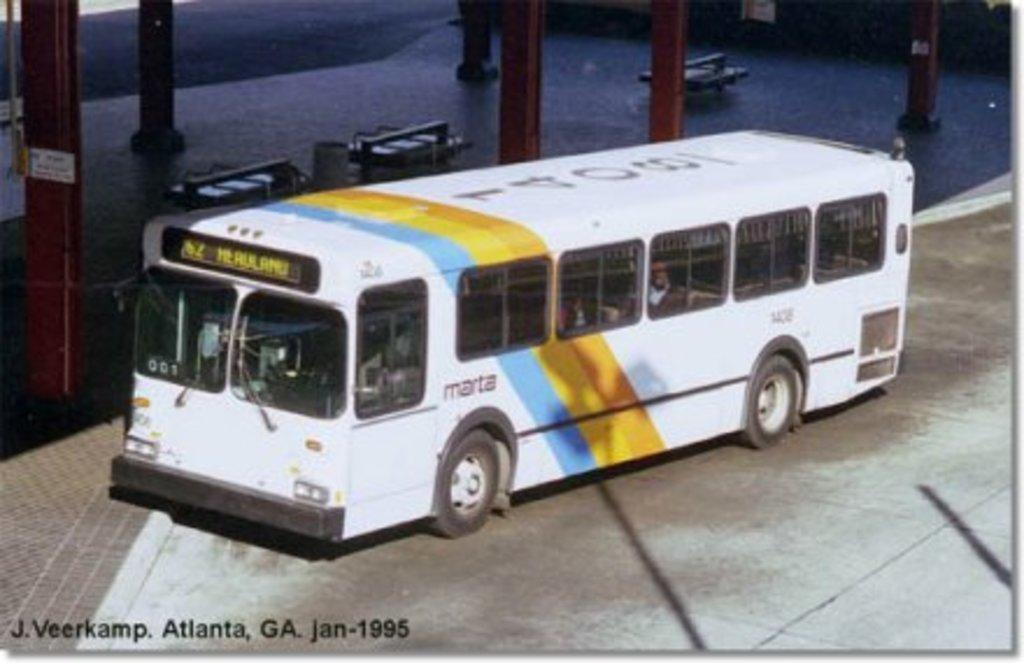Provide a one-sentence caption for the provided image. A Marta bus is parked by an empty covered waiting area. 